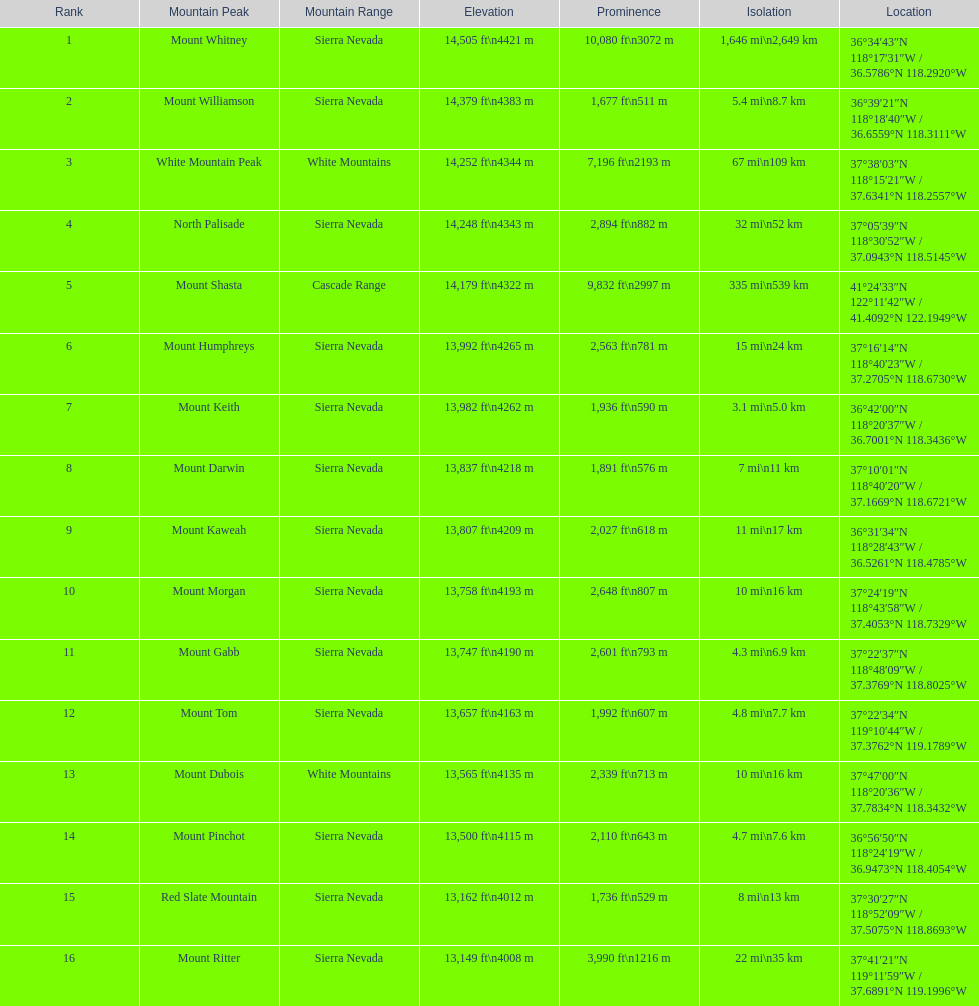Which mountain apex possesses a prominence over 10,000 ft? Mount Whitney. 